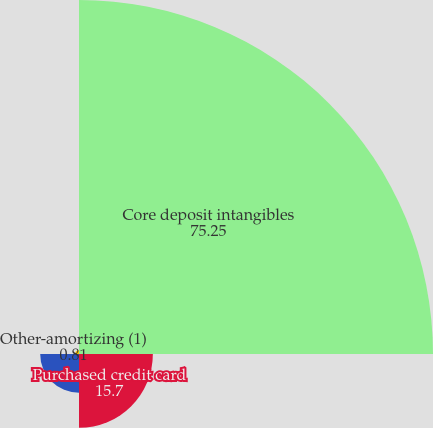Convert chart. <chart><loc_0><loc_0><loc_500><loc_500><pie_chart><fcel>Core deposit intangibles<fcel>Purchased credit card<fcel>Customer relationship and<fcel>Other-amortizing (1)<nl><fcel>75.25%<fcel>15.7%<fcel>8.25%<fcel>0.81%<nl></chart> 